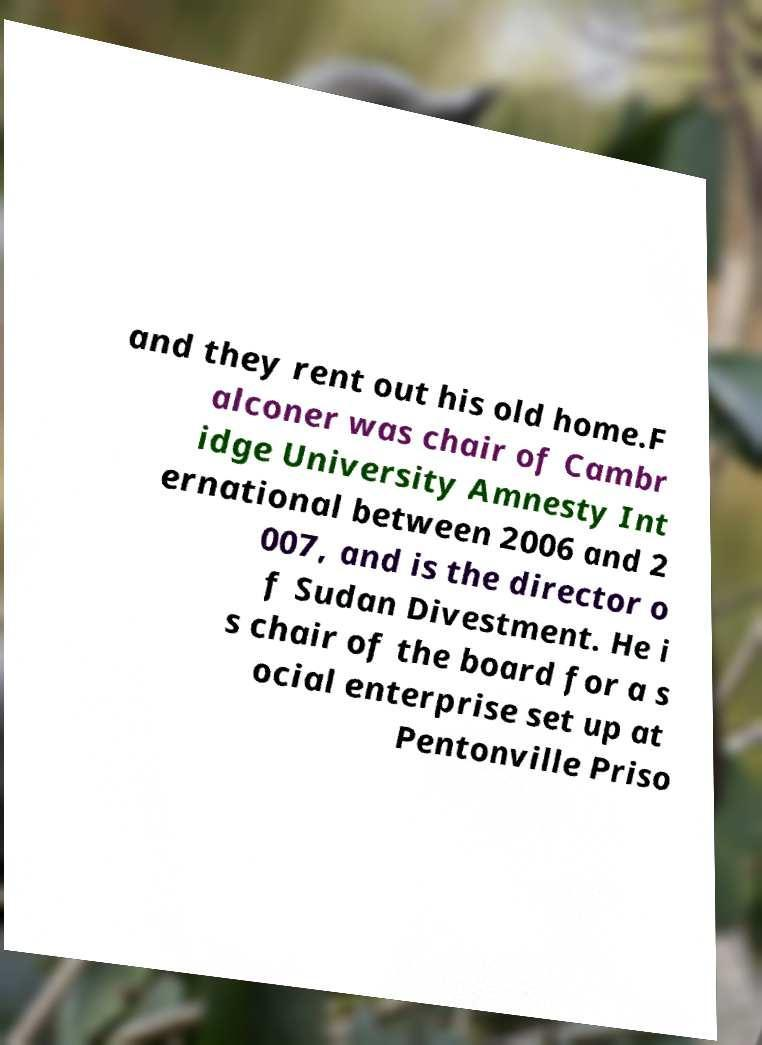I need the written content from this picture converted into text. Can you do that? and they rent out his old home.F alconer was chair of Cambr idge University Amnesty Int ernational between 2006 and 2 007, and is the director o f Sudan Divestment. He i s chair of the board for a s ocial enterprise set up at Pentonville Priso 